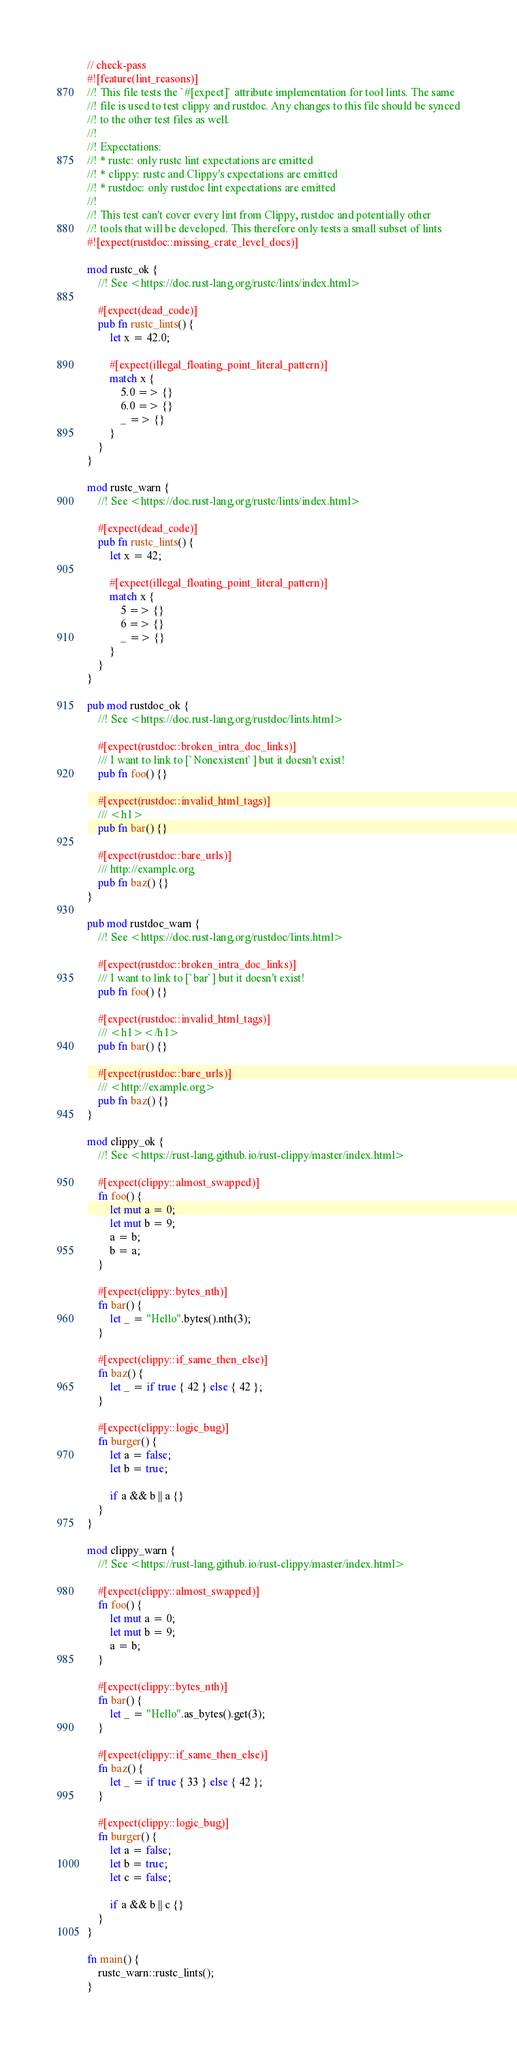<code> <loc_0><loc_0><loc_500><loc_500><_Rust_>// check-pass
#![feature(lint_reasons)]
//! This file tests the `#[expect]` attribute implementation for tool lints. The same
//! file is used to test clippy and rustdoc. Any changes to this file should be synced
//! to the other test files as well.
//!
//! Expectations:
//! * rustc: only rustc lint expectations are emitted
//! * clippy: rustc and Clippy's expectations are emitted
//! * rustdoc: only rustdoc lint expectations are emitted
//!
//! This test can't cover every lint from Clippy, rustdoc and potentially other
//! tools that will be developed. This therefore only tests a small subset of lints
#![expect(rustdoc::missing_crate_level_docs)]

mod rustc_ok {
    //! See <https://doc.rust-lang.org/rustc/lints/index.html>

    #[expect(dead_code)]
    pub fn rustc_lints() {
        let x = 42.0;

        #[expect(illegal_floating_point_literal_pattern)]
        match x {
            5.0 => {}
            6.0 => {}
            _ => {}
        }
    }
}

mod rustc_warn {
    //! See <https://doc.rust-lang.org/rustc/lints/index.html>

    #[expect(dead_code)]
    pub fn rustc_lints() {
        let x = 42;

        #[expect(illegal_floating_point_literal_pattern)]
        match x {
            5 => {}
            6 => {}
            _ => {}
        }
    }
}

pub mod rustdoc_ok {
    //! See <https://doc.rust-lang.org/rustdoc/lints.html>

    #[expect(rustdoc::broken_intra_doc_links)]
    /// I want to link to [`Nonexistent`] but it doesn't exist!
    pub fn foo() {}

    #[expect(rustdoc::invalid_html_tags)]
    /// <h1>
    pub fn bar() {}

    #[expect(rustdoc::bare_urls)]
    /// http://example.org
    pub fn baz() {}
}

pub mod rustdoc_warn {
    //! See <https://doc.rust-lang.org/rustdoc/lints.html>

    #[expect(rustdoc::broken_intra_doc_links)]
    /// I want to link to [`bar`] but it doesn't exist!
    pub fn foo() {}

    #[expect(rustdoc::invalid_html_tags)]
    /// <h1></h1>
    pub fn bar() {}

    #[expect(rustdoc::bare_urls)]
    /// <http://example.org>
    pub fn baz() {}
}

mod clippy_ok {
    //! See <https://rust-lang.github.io/rust-clippy/master/index.html>

    #[expect(clippy::almost_swapped)]
    fn foo() {
        let mut a = 0;
        let mut b = 9;
        a = b;
        b = a;
    }

    #[expect(clippy::bytes_nth)]
    fn bar() {
        let _ = "Hello".bytes().nth(3);
    }

    #[expect(clippy::if_same_then_else)]
    fn baz() {
        let _ = if true { 42 } else { 42 };
    }

    #[expect(clippy::logic_bug)]
    fn burger() {
        let a = false;
        let b = true;

        if a && b || a {}
    }
}

mod clippy_warn {
    //! See <https://rust-lang.github.io/rust-clippy/master/index.html>

    #[expect(clippy::almost_swapped)]
    fn foo() {
        let mut a = 0;
        let mut b = 9;
        a = b;
    }

    #[expect(clippy::bytes_nth)]
    fn bar() {
        let _ = "Hello".as_bytes().get(3);
    }

    #[expect(clippy::if_same_then_else)]
    fn baz() {
        let _ = if true { 33 } else { 42 };
    }

    #[expect(clippy::logic_bug)]
    fn burger() {
        let a = false;
        let b = true;
        let c = false;

        if a && b || c {}
    }
}

fn main() {
    rustc_warn::rustc_lints();
}
</code> 